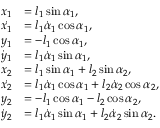Convert formula to latex. <formula><loc_0><loc_0><loc_500><loc_500>\begin{array} { r l } { x _ { 1 } } & { = l _ { 1 } \sin \alpha _ { 1 } , } \\ { \dot { x _ { 1 } } } & { = l _ { 1 } \dot { \alpha } _ { 1 } \cos \alpha _ { 1 } , } \\ { y _ { 1 } } & { = - l _ { 1 } \cos \alpha _ { 1 } , } \\ { \dot { y } _ { 1 } } & { = l _ { 1 } \dot { \alpha } _ { 1 } \sin \alpha _ { 1 } , } \\ { x _ { 2 } } & { = l _ { 1 } \sin \alpha _ { 1 } + l _ { 2 } \sin \alpha _ { 2 } , } \\ { \dot { x _ { 2 } } } & { = l _ { 1 } \dot { \alpha } _ { 1 } \cos \alpha _ { 1 } + l _ { 2 } \dot { \alpha } _ { 2 } \cos \alpha _ { 2 } , } \\ { y _ { 2 } } & { = - l _ { 1 } \cos \alpha _ { 1 } - l _ { 2 } \cos \alpha _ { 2 } , } \\ { \dot { y } _ { 2 } } & { = l _ { 1 } \dot { \alpha } _ { 1 } \sin \alpha _ { 1 } + l _ { 2 } \dot { \alpha } _ { 2 } \sin \alpha _ { 2 } . } \end{array}</formula> 